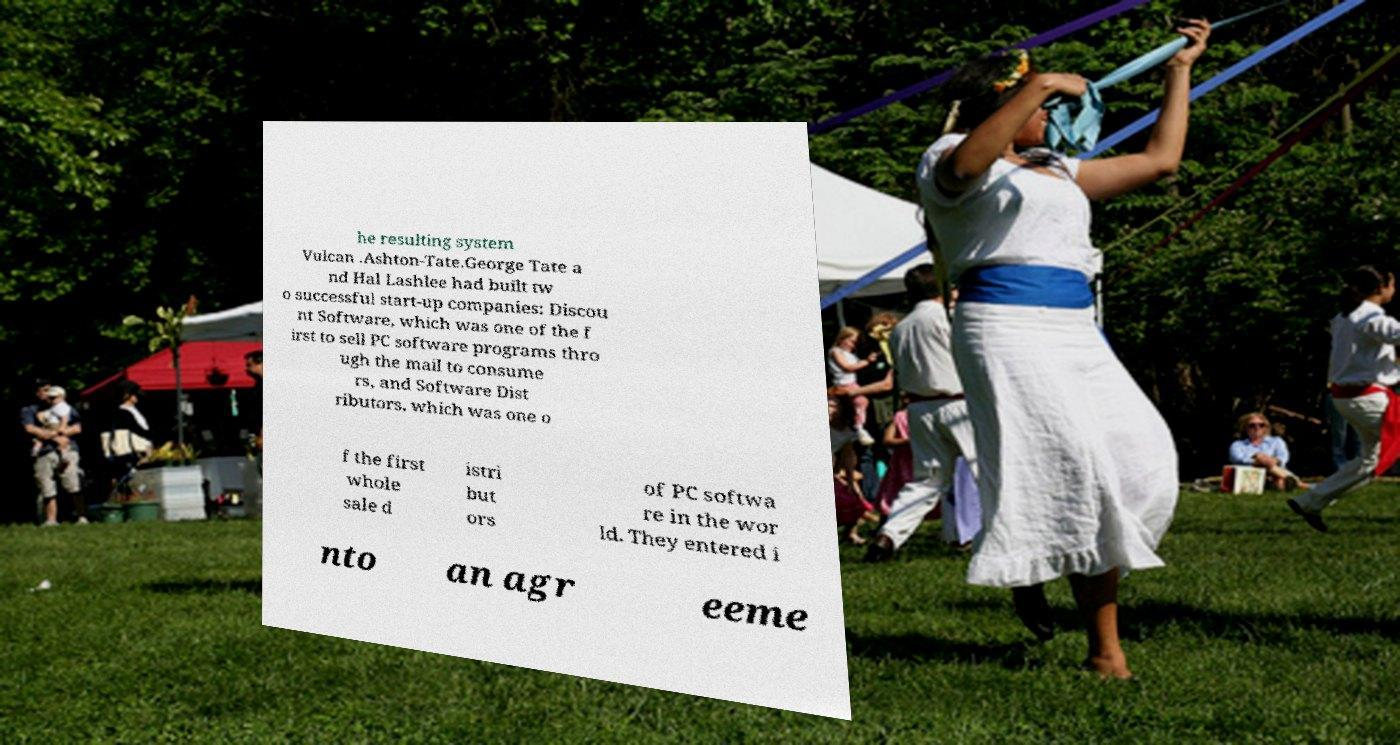For documentation purposes, I need the text within this image transcribed. Could you provide that? he resulting system Vulcan .Ashton-Tate.George Tate a nd Hal Lashlee had built tw o successful start-up companies: Discou nt Software, which was one of the f irst to sell PC software programs thro ugh the mail to consume rs, and Software Dist ributors, which was one o f the first whole sale d istri but ors of PC softwa re in the wor ld. They entered i nto an agr eeme 